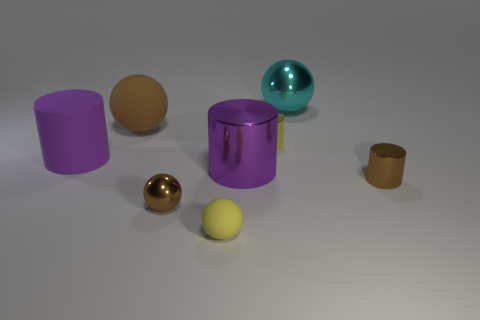Subtract all big brown rubber balls. How many balls are left? 3 Subtract all cyan spheres. How many spheres are left? 3 Add 1 large rubber blocks. How many objects exist? 9 Subtract 1 cyan balls. How many objects are left? 7 Subtract all green cylinders. Subtract all cyan blocks. How many cylinders are left? 4 Subtract all yellow cylinders. How many brown balls are left? 2 Subtract all brown spheres. Subtract all tiny rubber things. How many objects are left? 5 Add 5 yellow shiny cylinders. How many yellow shiny cylinders are left? 6 Add 6 small metal cylinders. How many small metal cylinders exist? 8 